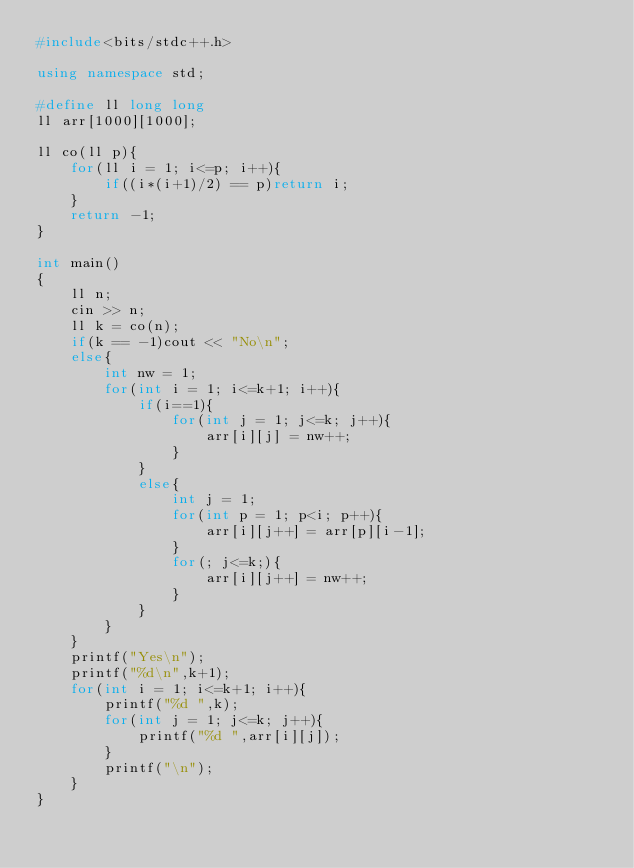Convert code to text. <code><loc_0><loc_0><loc_500><loc_500><_C++_>#include<bits/stdc++.h>

using namespace std;

#define ll long long
ll arr[1000][1000];

ll co(ll p){
    for(ll i = 1; i<=p; i++){
        if((i*(i+1)/2) == p)return i;
    }
    return -1;
}

int main()
{
    ll n;
    cin >> n;
    ll k = co(n);
    if(k == -1)cout << "No\n";
    else{
        int nw = 1;
        for(int i = 1; i<=k+1; i++){
            if(i==1){
                for(int j = 1; j<=k; j++){
                    arr[i][j] = nw++;
                }
            }
            else{
                int j = 1;
                for(int p = 1; p<i; p++){
                    arr[i][j++] = arr[p][i-1];
                }
                for(; j<=k;){
                    arr[i][j++] = nw++;
                }
            }
        }
    }
    printf("Yes\n");
    printf("%d\n",k+1);
    for(int i = 1; i<=k+1; i++){
        printf("%d ",k);
        for(int j = 1; j<=k; j++){
            printf("%d ",arr[i][j]);
        }
        printf("\n");
    }
}
</code> 